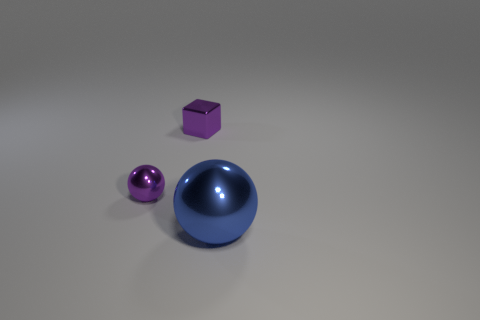Add 3 tiny gray cylinders. How many objects exist? 6 Subtract all spheres. How many objects are left? 1 Subtract 1 purple blocks. How many objects are left? 2 Subtract all tiny blocks. Subtract all big blue balls. How many objects are left? 1 Add 1 shiny balls. How many shiny balls are left? 3 Add 3 shiny objects. How many shiny objects exist? 6 